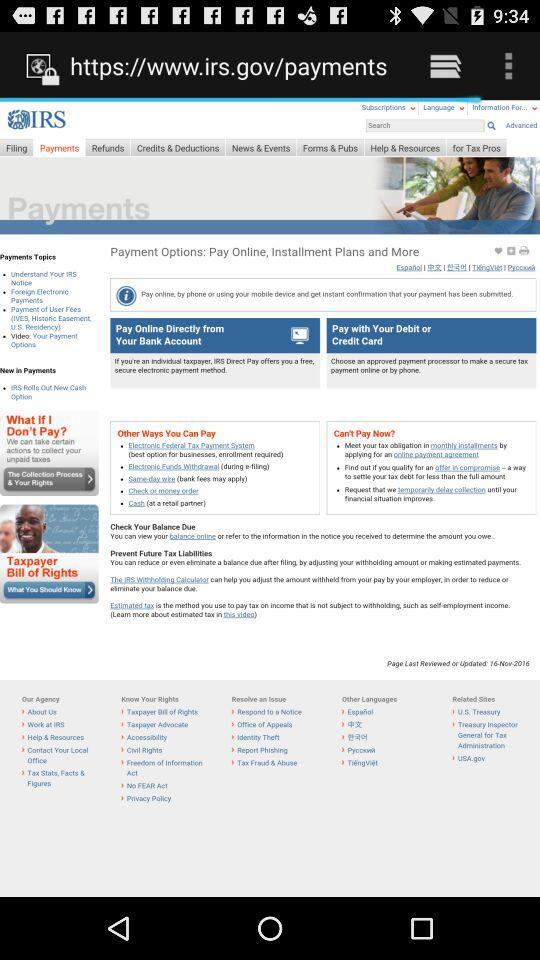Which tab is selected? The selected tab is "Payments". 